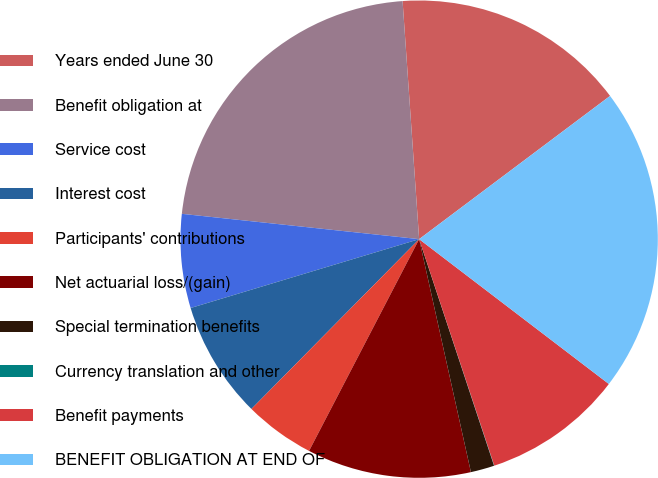<chart> <loc_0><loc_0><loc_500><loc_500><pie_chart><fcel>Years ended June 30<fcel>Benefit obligation at<fcel>Service cost<fcel>Interest cost<fcel>Participants' contributions<fcel>Net actuarial loss/(gain)<fcel>Special termination benefits<fcel>Currency translation and other<fcel>Benefit payments<fcel>BENEFIT OBLIGATION AT END OF<nl><fcel>15.86%<fcel>22.2%<fcel>6.35%<fcel>7.94%<fcel>4.77%<fcel>11.11%<fcel>1.6%<fcel>0.02%<fcel>9.52%<fcel>20.62%<nl></chart> 